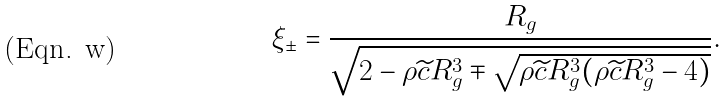<formula> <loc_0><loc_0><loc_500><loc_500>\xi _ { \pm } = \frac { R _ { g } } { \sqrt { 2 - \rho \widetilde { c } R _ { g } ^ { 3 } \mp \sqrt { \rho \widetilde { c } R _ { g } ^ { 3 } ( \rho \widetilde { c } R _ { g } ^ { 3 } - 4 ) } } } .</formula> 